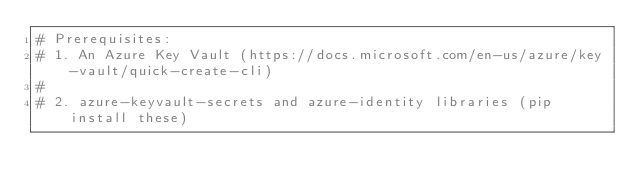<code> <loc_0><loc_0><loc_500><loc_500><_Python_># Prerequisites:
# 1. An Azure Key Vault (https://docs.microsoft.com/en-us/azure/key-vault/quick-create-cli)
#
# 2. azure-keyvault-secrets and azure-identity libraries (pip install these)</code> 